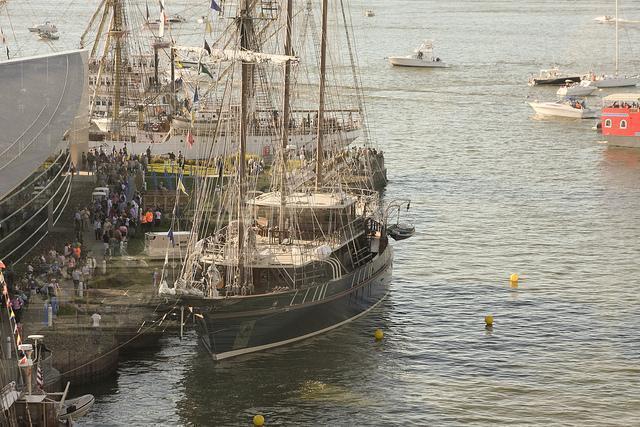How many boats are visible?
Give a very brief answer. 2. 